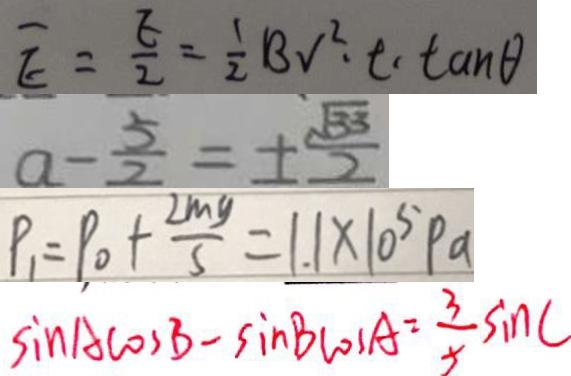<formula> <loc_0><loc_0><loc_500><loc_500>\overline { E } = \frac { E } { 2 } = \frac { 1 } { 2 } B V ^ { 2 } \cdot t \cdot \tan \theta 
 a - \frac { 5 } { 2 } = \pm \frac { \sqrt { 3 3 } } { 2 } 
 P _ { 1 } = P _ { 0 } + \frac { 2 m g } { s } = 1 . 1 \times 1 0 ^ { 5 } P a 
 \sin A \cos B - \sin B \cos A = \frac { 3 } { 5 } \sin C</formula> 